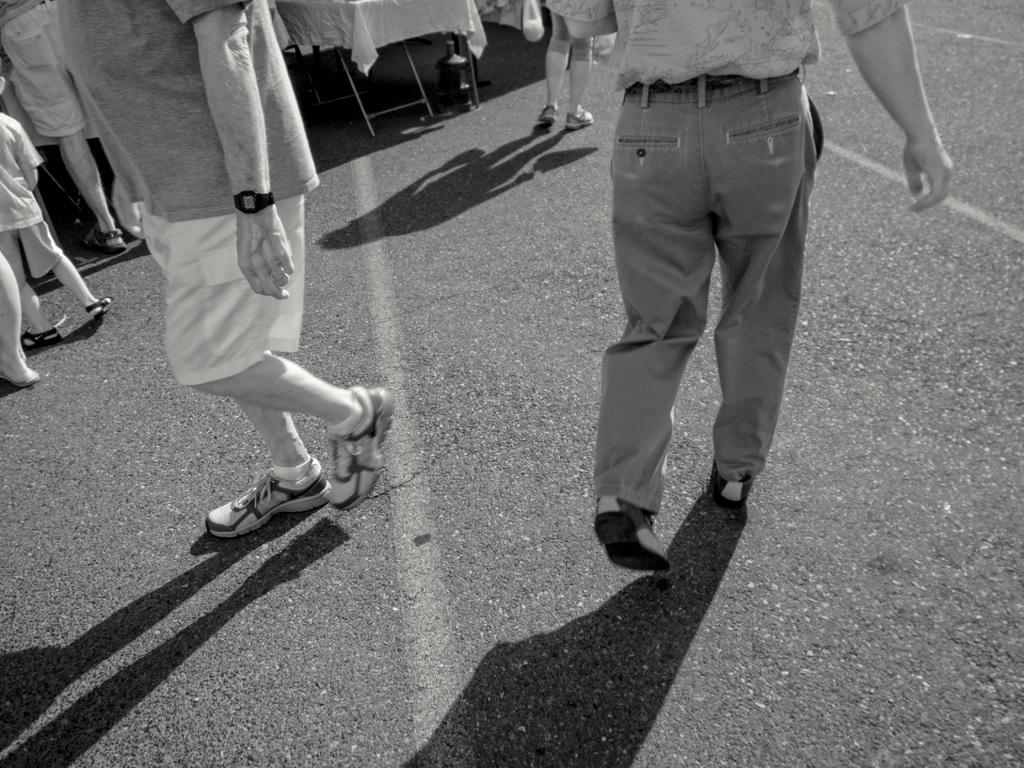What is the main feature of the image? There is a road in the image. What are the people in the image doing? There are people standing and people walking in the image. Where is the mailbox located in the image? There is no mailbox present in the image. What type of vessel is being used by the people walking in the image? There is no vessel present in the image; the people are walking on a road. 